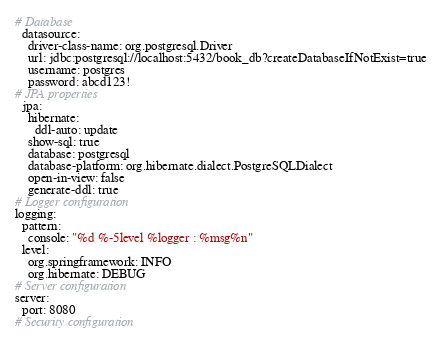<code> <loc_0><loc_0><loc_500><loc_500><_YAML_># Database
  datasource:
    driver-class-name: org.postgresql.Driver
    url: jdbc:postgresql://localhost:5432/book_db?createDatabaseIfNotExist=true
    username: postgres
    password: abcd123!
# JPA properties
  jpa:
    hibernate:
      ddl-auto: update
    show-sql: true
    database: postgresql
    database-platform: org.hibernate.dialect.PostgreSQLDialect
    open-in-view: false
    generate-ddl: true
# Logger configuration
logging:
  pattern:
    console: "%d %-5level %logger : %msg%n"
  level:
    org.springframework: INFO
    org.hibernate: DEBUG
# Server configuration
server:
  port: 8080
# Security configuration

</code> 